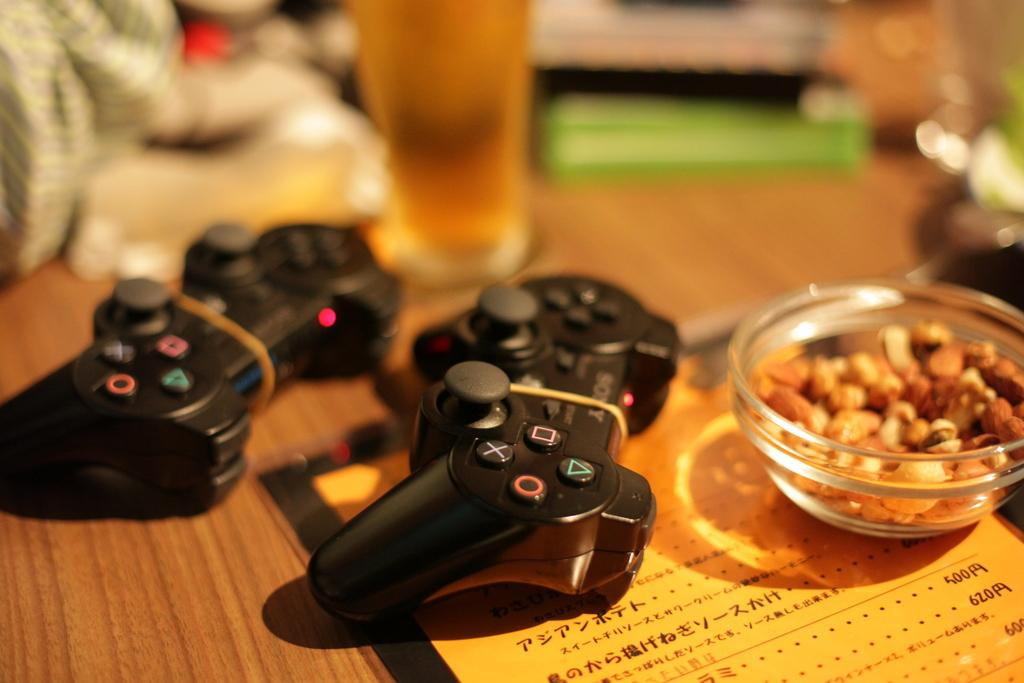What is contained in the glass that is visible in the image? There is a glass of liquid in the image. What type of electronic devices are present in the image? There are video game remotes in the image. What type of food is in the bowl that is visible in the image? There is a bowl of dry fruits in the image. What is the text card placed on in the image? The text card is placed on a wooden surface in the image. Can you describe the visual quality of any part of the image? Some part of the image is blurred. Can you tell me how many friends are visible in the image? There are no friends visible in the image. What type of wall is present in the image? There is no wall present in the image. 